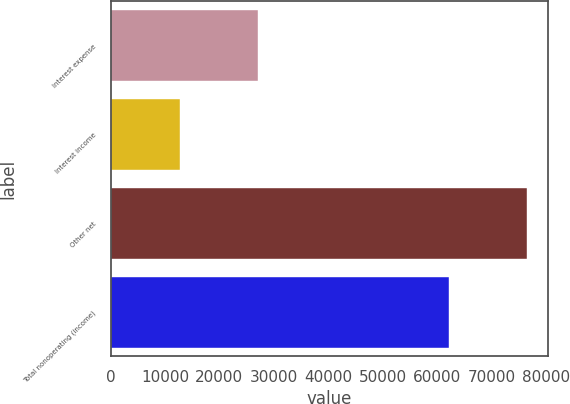Convert chart. <chart><loc_0><loc_0><loc_500><loc_500><bar_chart><fcel>Interest expense<fcel>Interest income<fcel>Other net<fcel>Total nonoperating (income)<nl><fcel>27102<fcel>12753<fcel>76597<fcel>62248<nl></chart> 